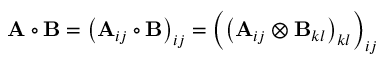<formula> <loc_0><loc_0><loc_500><loc_500>A \circ B = \left ( A _ { i j } \circ B \right ) _ { i j } = \left ( \left ( A _ { i j } \otimes B _ { k l } \right ) _ { k l } \right ) _ { i j }</formula> 